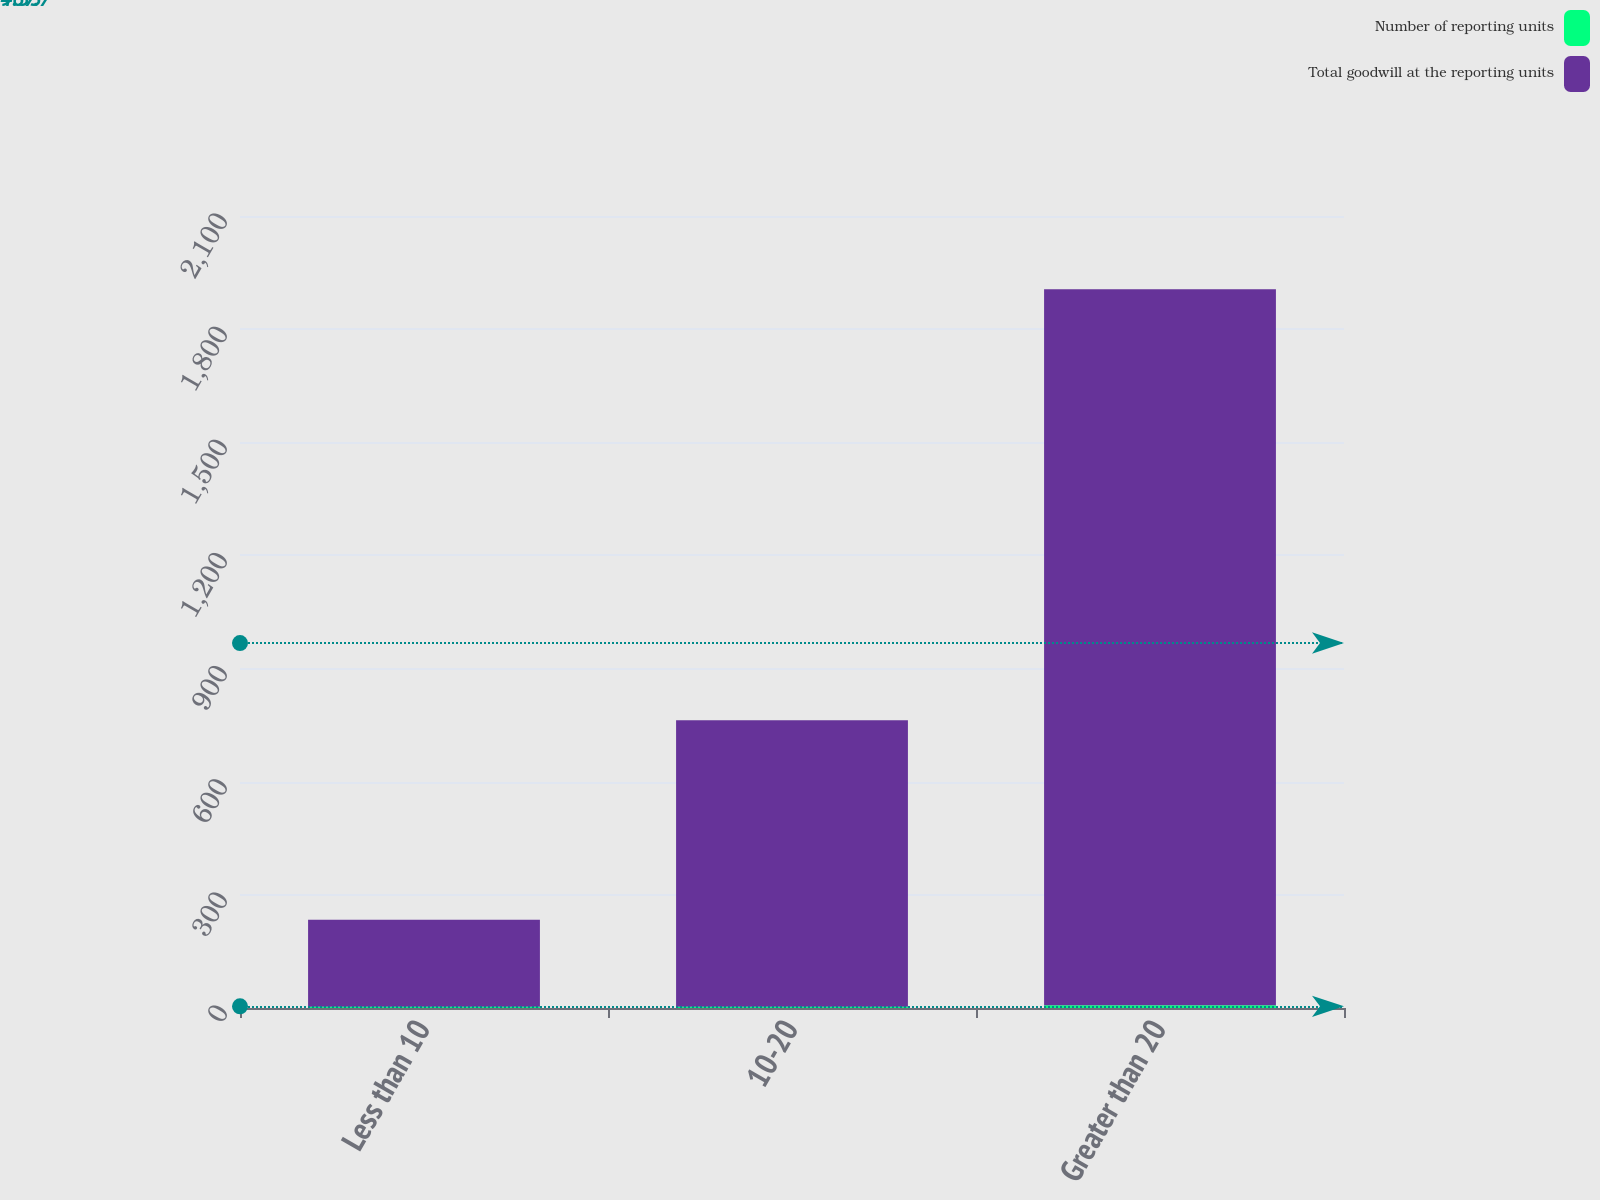Convert chart to OTSL. <chart><loc_0><loc_0><loc_500><loc_500><stacked_bar_chart><ecel><fcel>Less than 10<fcel>10-20<fcel>Greater than 20<nl><fcel>Number of reporting units<fcel>3<fcel>3<fcel>7<nl><fcel>Total goodwill at the reporting units<fcel>231.1<fcel>759.9<fcel>1899.1<nl></chart> 